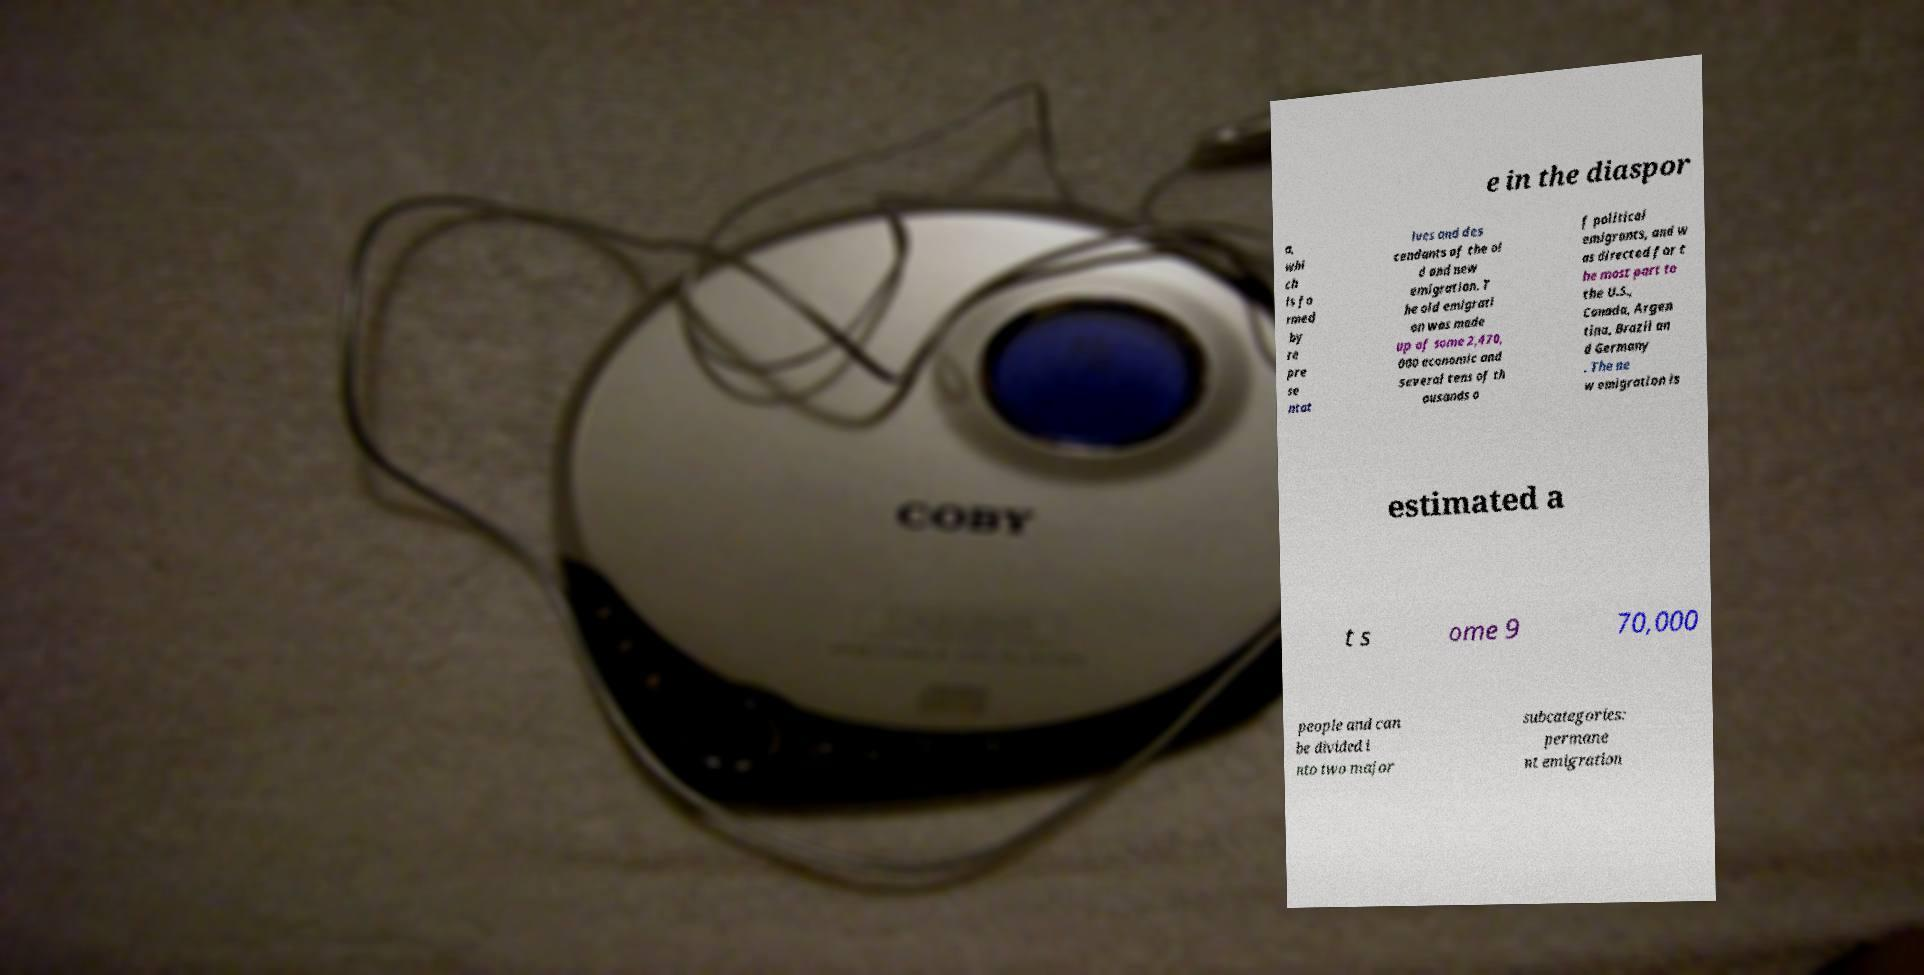There's text embedded in this image that I need extracted. Can you transcribe it verbatim? e in the diaspor a, whi ch is fo rmed by re pre se ntat ives and des cendants of the ol d and new emigration. T he old emigrati on was made up of some 2,470, 000 economic and several tens of th ousands o f political emigrants, and w as directed for t he most part to the U.S., Canada, Argen tina, Brazil an d Germany . The ne w emigration is estimated a t s ome 9 70,000 people and can be divided i nto two major subcategories: permane nt emigration 